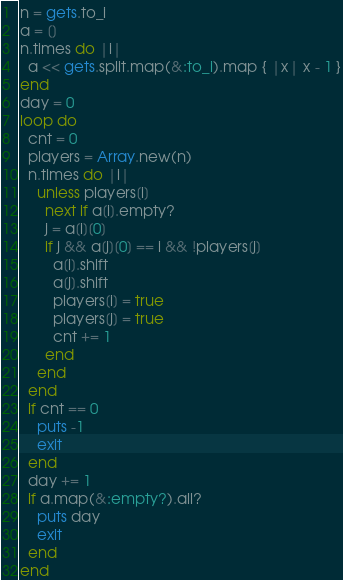<code> <loc_0><loc_0><loc_500><loc_500><_Ruby_>n = gets.to_i
a = []
n.times do |i|
  a << gets.split.map(&:to_i).map { |x| x - 1 }
end
day = 0
loop do
  cnt = 0
  players = Array.new(n)
  n.times do |i|
    unless players[i]
      next if a[i].empty?
      j = a[i][0]
      if j && a[j][0] == i && !players[j]
        a[i].shift
        a[j].shift
        players[i] = true
        players[j] = true
        cnt += 1
      end
    end
  end
  if cnt == 0
    puts -1
    exit
  end
  day += 1
  if a.map(&:empty?).all?
    puts day
    exit
  end
end
</code> 